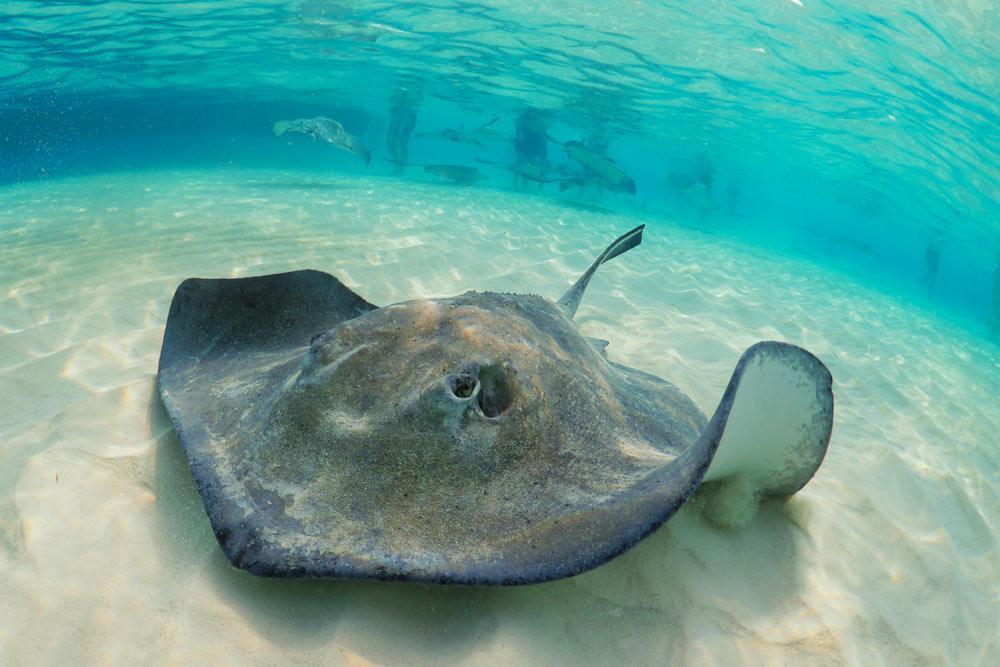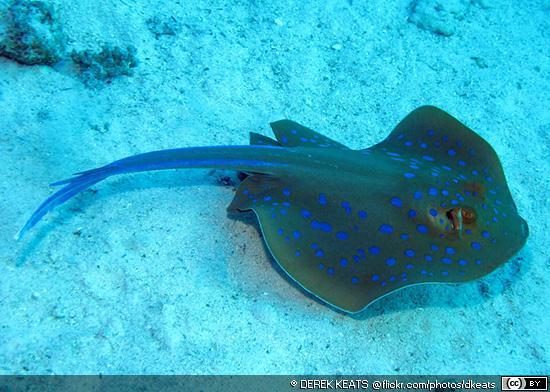The first image is the image on the left, the second image is the image on the right. Assess this claim about the two images: "An image contains a human touching a sting ray.". Correct or not? Answer yes or no. No. The first image is the image on the left, the second image is the image on the right. Considering the images on both sides, is "A person whose head and chest are above water is behind a stingray in the ocean." valid? Answer yes or no. No. 